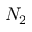Convert formula to latex. <formula><loc_0><loc_0><loc_500><loc_500>N _ { 2 }</formula> 